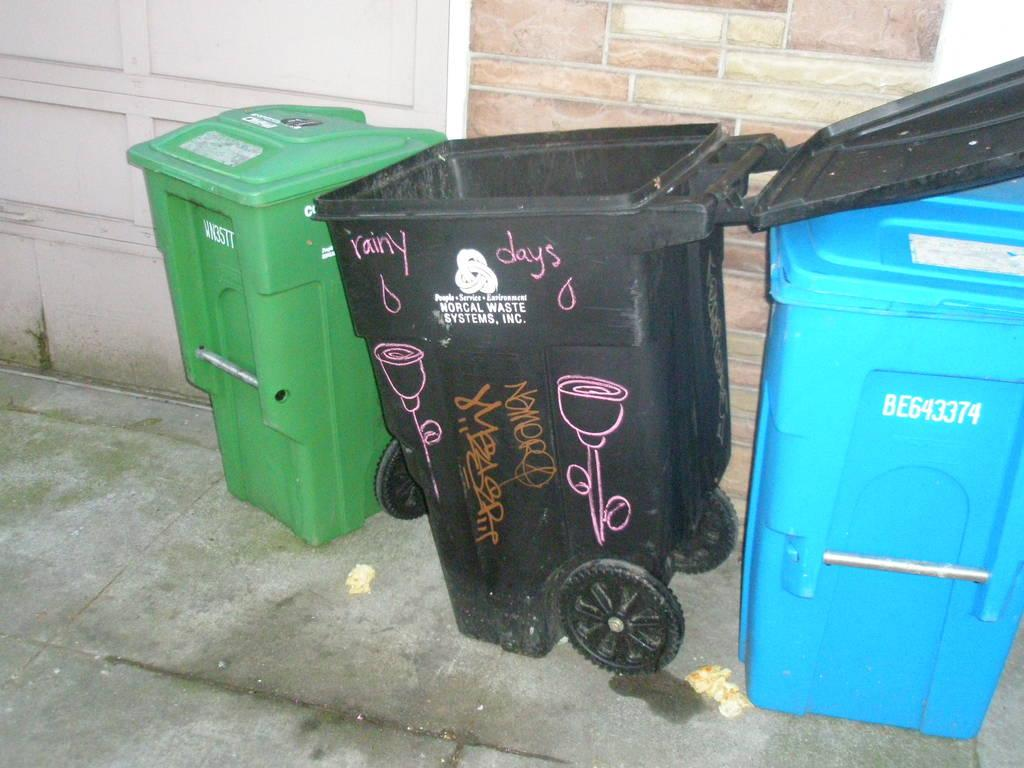<image>
Provide a brief description of the given image. A black garbage pail has Rainy Days painted on it. 